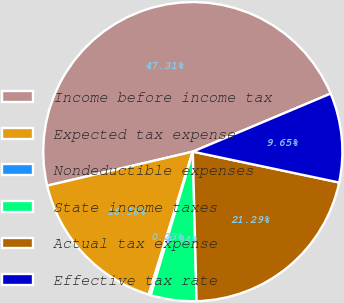Convert chart. <chart><loc_0><loc_0><loc_500><loc_500><pie_chart><fcel>Income before income tax<fcel>Expected tax expense<fcel>Nondeductible expenses<fcel>State income taxes<fcel>Actual tax expense<fcel>Effective tax rate<nl><fcel>47.31%<fcel>16.58%<fcel>0.23%<fcel>4.94%<fcel>21.29%<fcel>9.65%<nl></chart> 